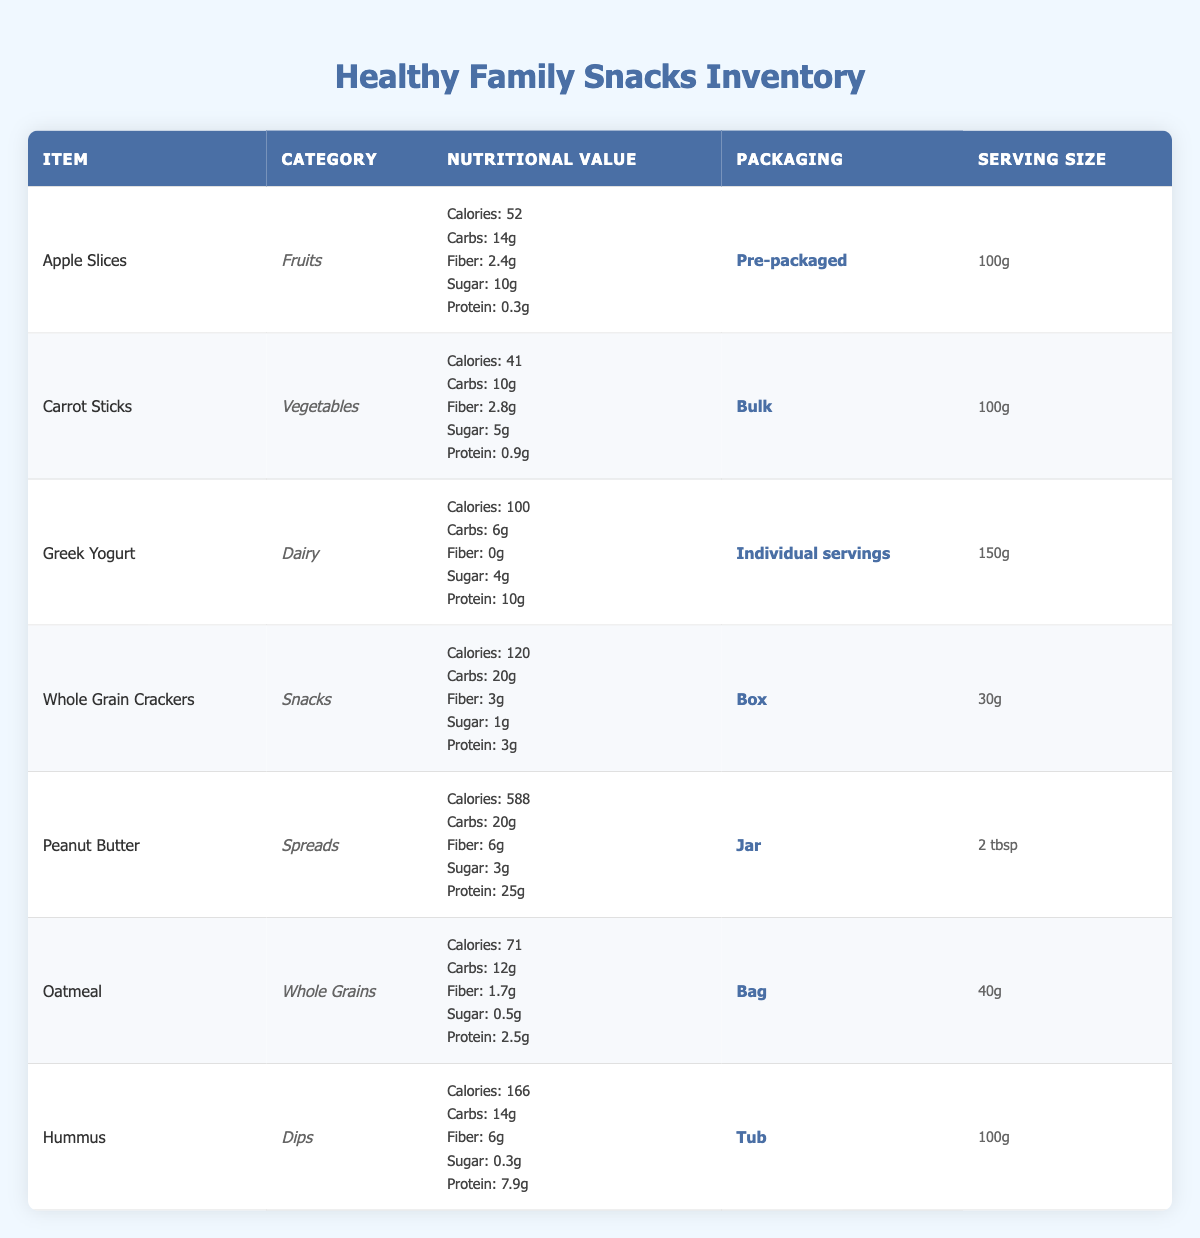What is the total calorie count for Greek Yogurt and Hummus? The caloric values are listed as follows: Greek Yogurt has 100 calories and Hummus has 166 calories. To find the total, we add these two values together: 100 + 166 = 266 calories.
Answer: 266 calories How much protein does Whole Grain Crackers contain? According to the table, Whole Grain Crackers have a nutritional value indicating they contain 3 grams of protein per serving.
Answer: 3 grams Which item has the highest sugar content? By examining the sugar content of each item, we find that Apple Slices contain 10 grams of sugar, while other items have less. Therefore, Apple Slices have the highest sugar content.
Answer: Apple Slices Is Hummus packaged in bulk? The packaging information shows that Hummus is packaged in a tub, which indicates it is not bulk. Therefore, the statement is false.
Answer: No What is the average carbohydrate content of the fruits listed in the inventory? We have one fruit item: Apple Slices, which contains 14 grams of carbohydrates. Since there is only one item, the average is equal to the carbohydrate value of the Apple Slices: 14 grams.
Answer: 14 grams What is the serving size of Peanut Butter? The table states that the serving size for Peanut Butter is 2 tablespoons.
Answer: 2 tablespoons Which category does Carrot Sticks belong to? Referring to the category column, Carrot Sticks is listed under the category "Vegetables."
Answer: Vegetables What is the total fiber content for Oatmeal and Greek Yogurt combined? Oatmeal has 1.7 grams of fiber and Greek Yogurt has 0 grams of fiber. To find the total, we add the two values: 1.7 + 0 = 1.7 grams of fiber.
Answer: 1.7 grams 